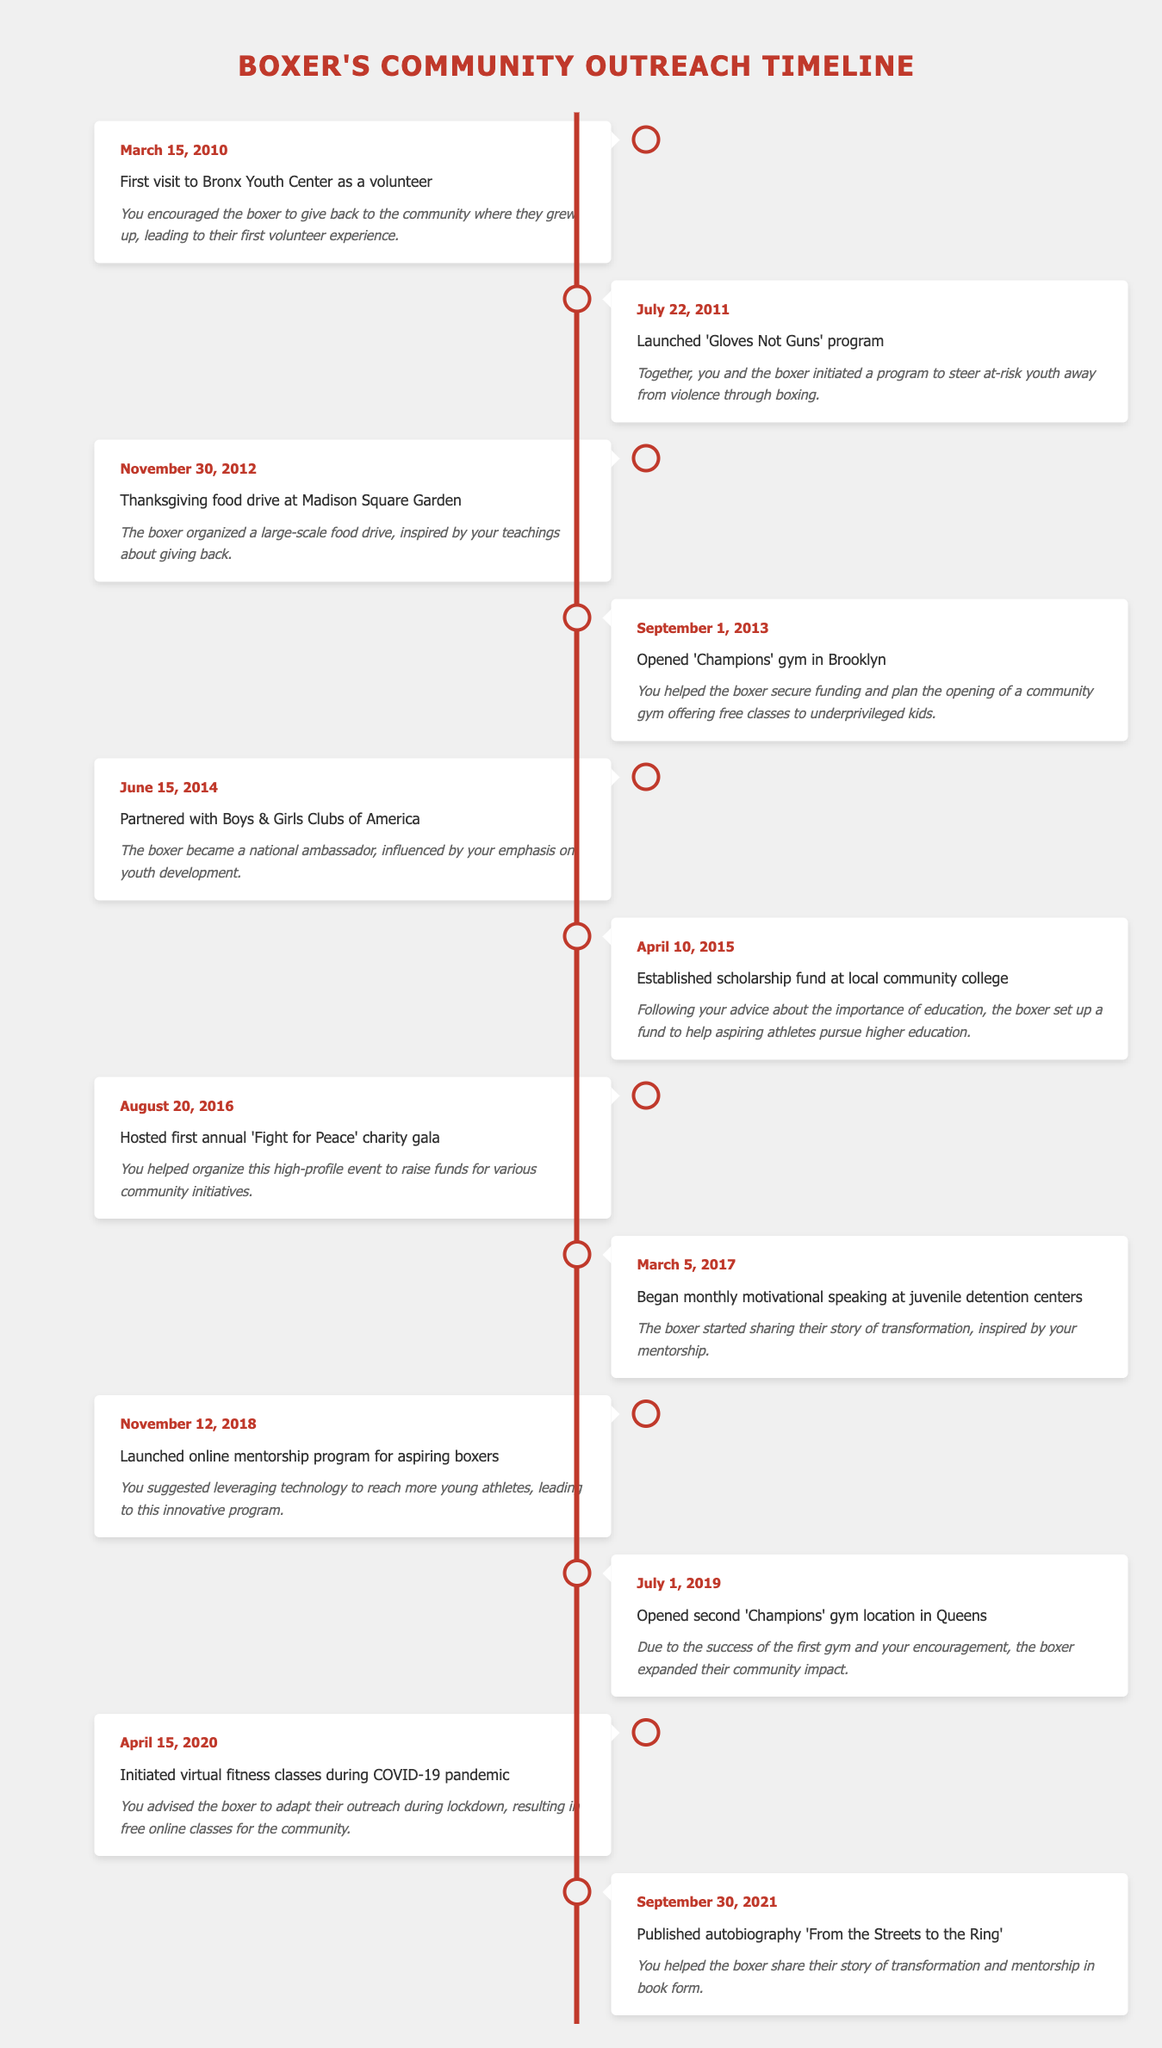What is the date of the first visit to Bronx Youth Center? The first visit to Bronx Youth Center as a volunteer happened on March 15, 2010, which is stated in the table.
Answer: March 15, 2010 How many community outreach events occurred in 2013? According to the table, two events took place in 2013: the opening of 'Champions' gym in Brooklyn on September 1 and no other event listed for that year, thus indicating only one event.
Answer: 1 Did the boxer launch any programs in 2014? Yes, the boxer partnered with Boys & Girls Clubs of America on June 15, 2014, as shown in the table.
Answer: Yes What was the total number of outreach activities organized between 2010 and 2015? From the table, the events between 2010 and 2015 are: 2010 (1), 2011 (1), 2012 (1), 2013 (1), 2014 (1), and 2015 (1), summing up gives us a total of 6 activities.
Answer: 6 When was the 'Fight for Peace' charity gala hosted? The first annual 'Fight for Peace' charity gala was hosted on August 20, 2016, as listed in the timeline.
Answer: August 20, 2016 What is the difference in years between the launch of the online mentorship program and the publication of the autobiography? The online mentorship program was launched on November 12, 2018, and the autobiography was published on September 30, 2021. The difference in years is 2021 - 2018 = 3 years.
Answer: 3 years How many events did the boxer host or participate in during the year 2020? In the year 2020, there was one event: the initiation of virtual fitness classes on April 15, 2020, which is mentioned in the table.
Answer: 1 What percentage of events involved partnerships with organizations in 2014? In total, there are 12 events listed in the table. In 2014, there is 1 event related to partnership, making the percentage (1/12) * 100 = 8.33%.
Answer: 8.33% Which event had the largest community impact based on its description? The opening of the 'Champions' gym in Brooklyn on September 1, 2013, is described as providing free classes to underprivileged kids, indicating significant community impact.
Answer: Opening 'Champions' gym in Brooklyn 